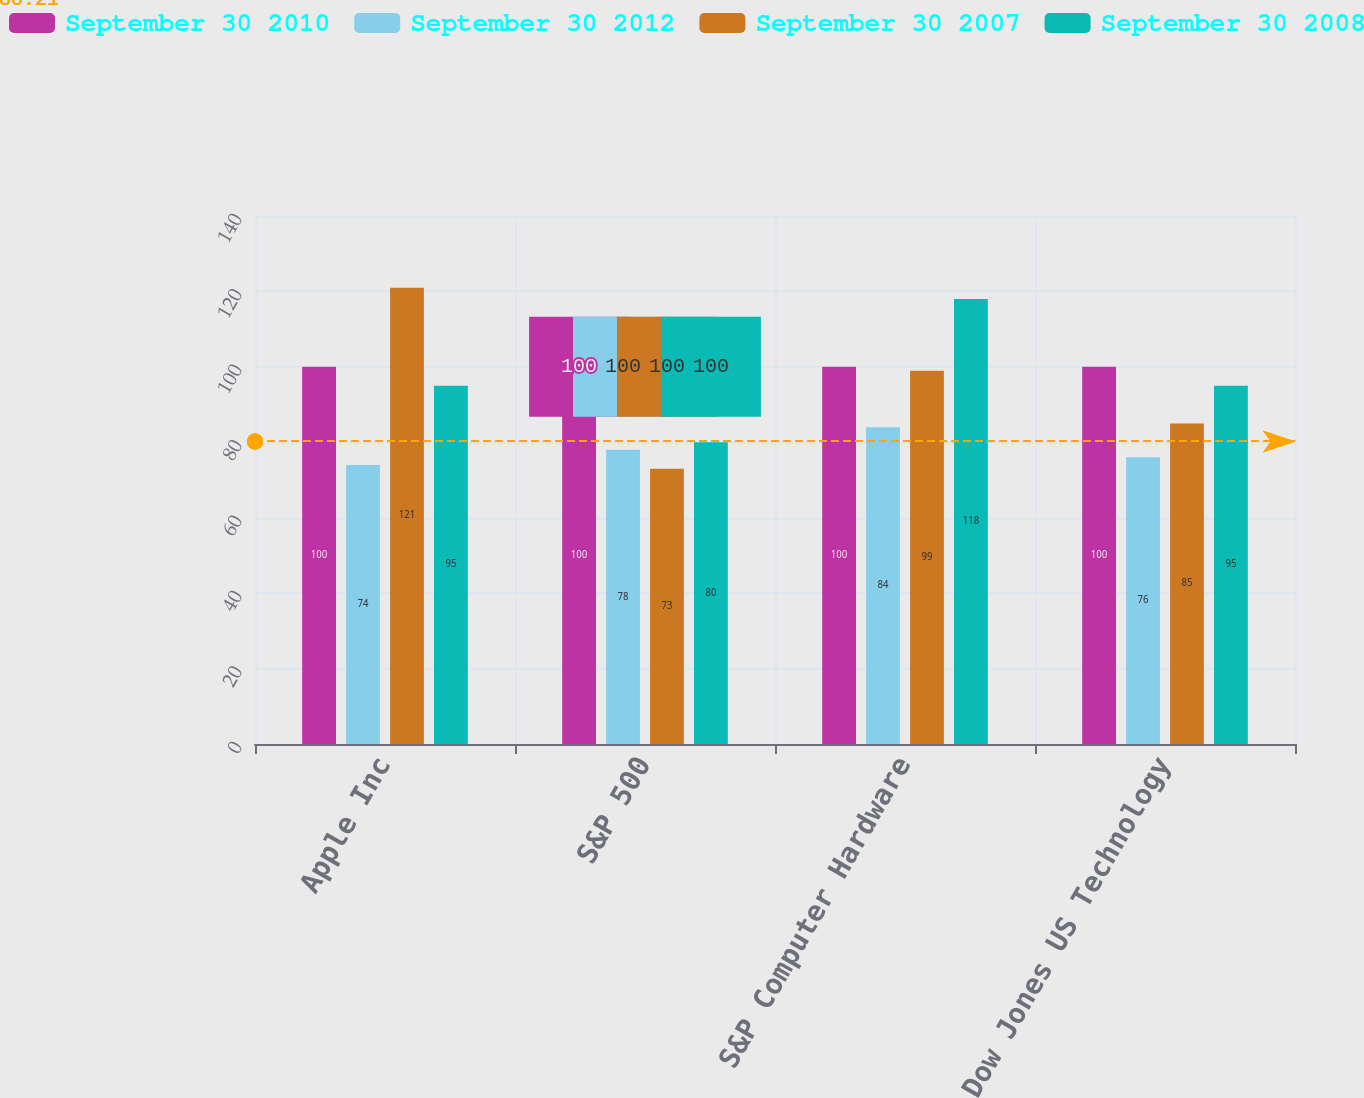<chart> <loc_0><loc_0><loc_500><loc_500><stacked_bar_chart><ecel><fcel>Apple Inc<fcel>S&P 500<fcel>S&P Computer Hardware<fcel>Dow Jones US Technology<nl><fcel>September 30 2010<fcel>100<fcel>100<fcel>100<fcel>100<nl><fcel>September 30 2012<fcel>74<fcel>78<fcel>84<fcel>76<nl><fcel>September 30 2007<fcel>121<fcel>73<fcel>99<fcel>85<nl><fcel>September 30 2008<fcel>95<fcel>80<fcel>118<fcel>95<nl></chart> 